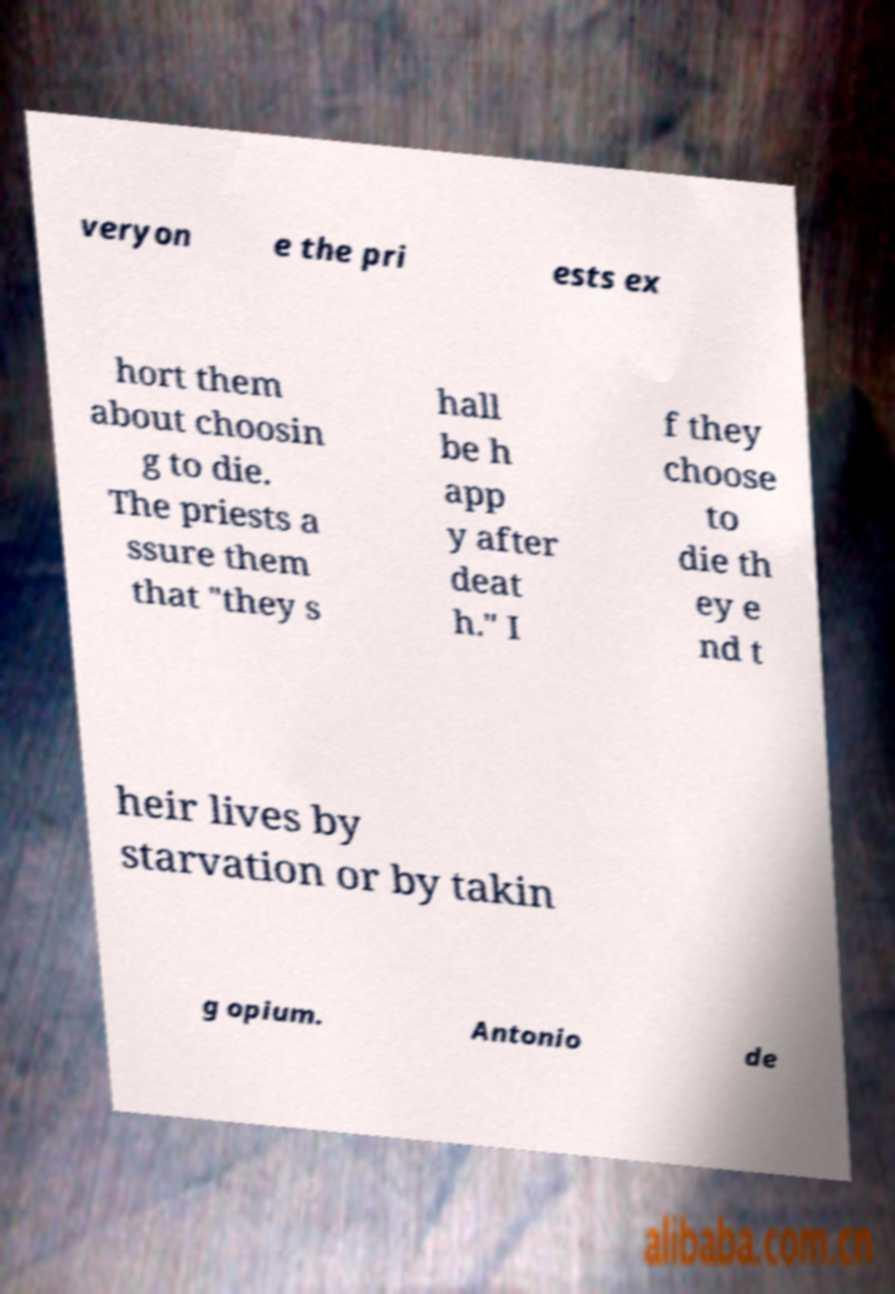Can you accurately transcribe the text from the provided image for me? veryon e the pri ests ex hort them about choosin g to die. The priests a ssure them that "they s hall be h app y after deat h." I f they choose to die th ey e nd t heir lives by starvation or by takin g opium. Antonio de 